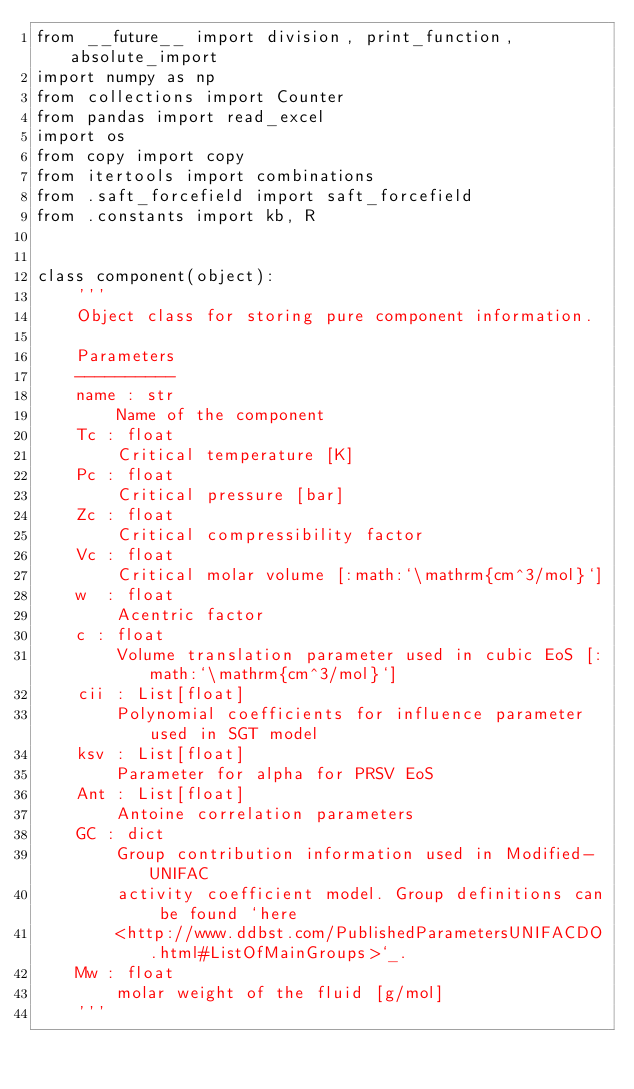<code> <loc_0><loc_0><loc_500><loc_500><_Python_>from __future__ import division, print_function, absolute_import
import numpy as np
from collections import Counter
from pandas import read_excel
import os
from copy import copy
from itertools import combinations
from .saft_forcefield import saft_forcefield
from .constants import kb, R


class component(object):
    '''
    Object class for storing pure component information.

    Parameters
    ----------
    name : str
        Name of the component
    Tc : float
        Critical temperature [K]
    Pc : float
        Critical pressure [bar]
    Zc : float
        Critical compressibility factor
    Vc : float
        Critical molar volume [:math:`\mathrm{cm^3/mol}`]
    w  : float
        Acentric factor
    c : float
        Volume translation parameter used in cubic EoS [:math:`\mathrm{cm^3/mol}`]
    cii : List[float]
        Polynomial coefficients for influence parameter used in SGT model
    ksv : List[float]
        Parameter for alpha for PRSV EoS
    Ant : List[float]
        Antoine correlation parameters
    GC : dict
        Group contribution information used in Modified-UNIFAC
        activity coefficient model. Group definitions can be found `here
        <http://www.ddbst.com/PublishedParametersUNIFACDO.html#ListOfMainGroups>`_.
    Mw : float
        molar weight of the fluid [g/mol]
    '''
</code> 